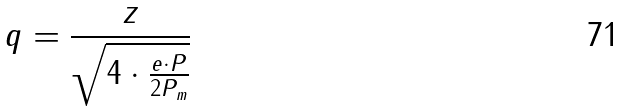Convert formula to latex. <formula><loc_0><loc_0><loc_500><loc_500>q = \frac { z } { \sqrt { 4 \cdot \frac { e \cdot P } { 2 P _ { m } } } }</formula> 